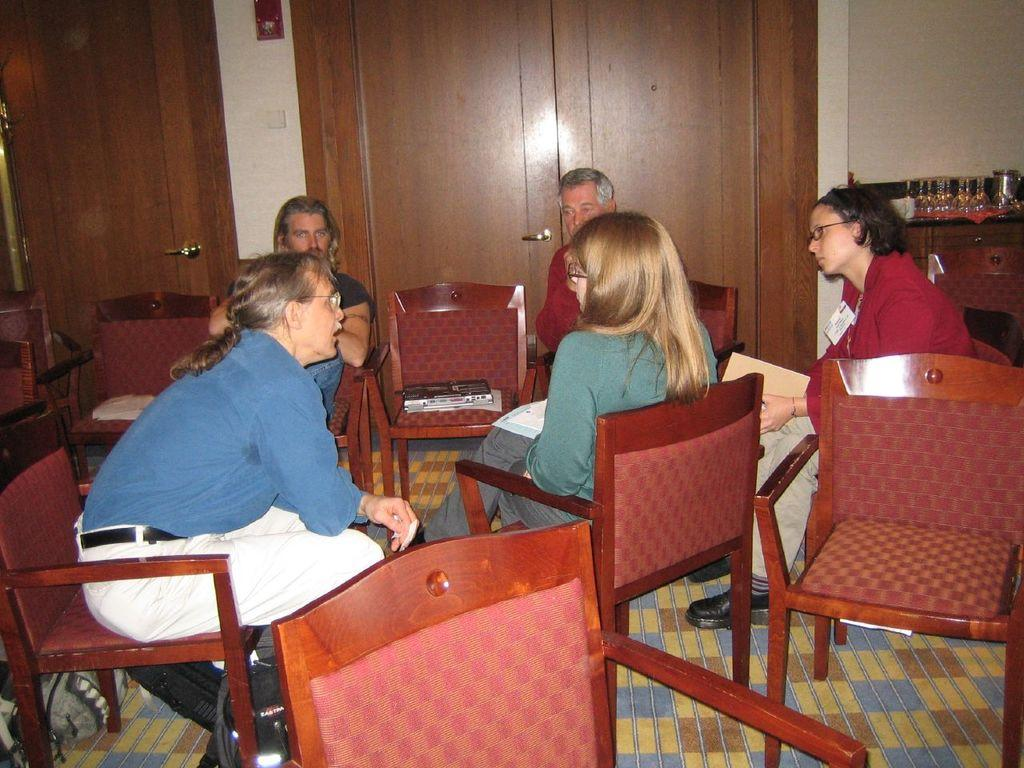How many people are in the image? There is a group of people in the image. What are the people doing in the image? The people are sitting in chairs. What can be seen on the table in the image? There are glasses and a jug on the table. What is the purpose of the door in the image? The door provides access to another room or area. What is on one of the chairs in the image? There is an object on one of the chairs. What type of patch can be seen on the ship in the image? There is no ship or patch present in the image. What sound can be heard coming from the object on the chair in the image? There is no sound associated with the object on the chair in the image. 